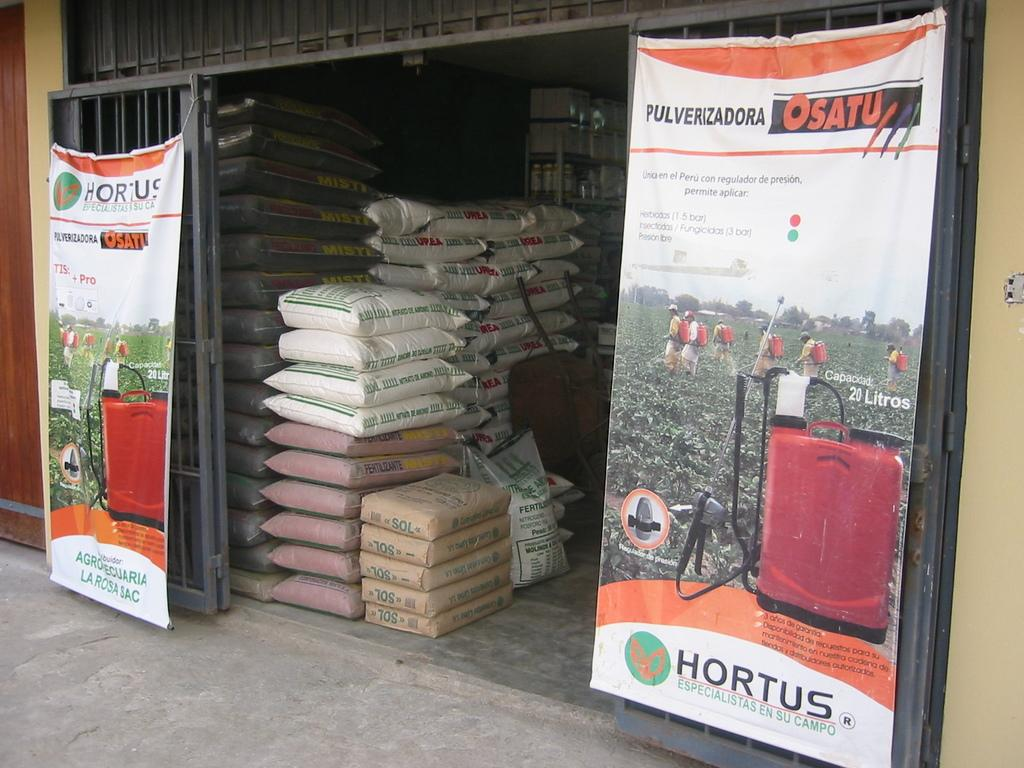What type of establishment is depicted in the image? There is a shop in the image. What can be seen on the walls of the shop? There are posters in the shop. What items are visible in the shop? There are packed bags in the shop. What type of stone is used to build the home in the image? There is no home present in the image, only a shop. 